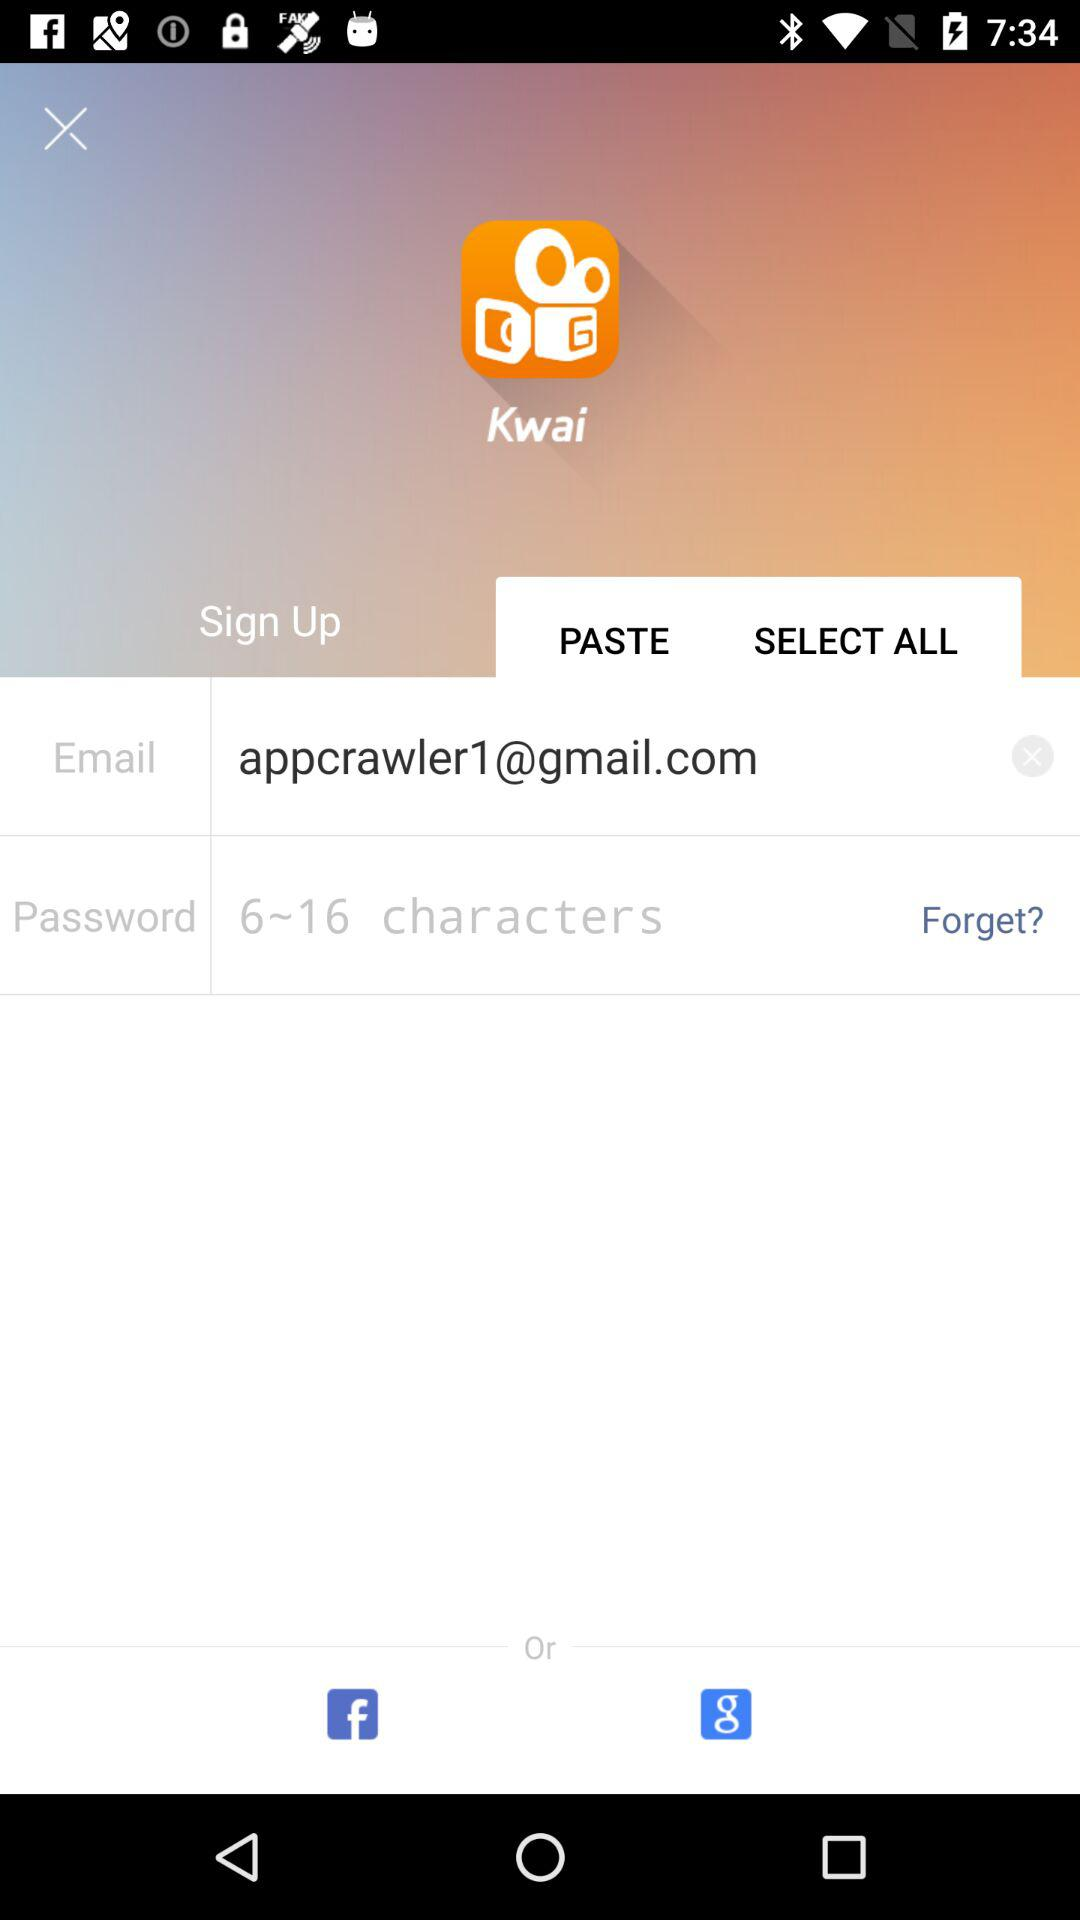What is the name of the application? The name of the application is "Kwai". 